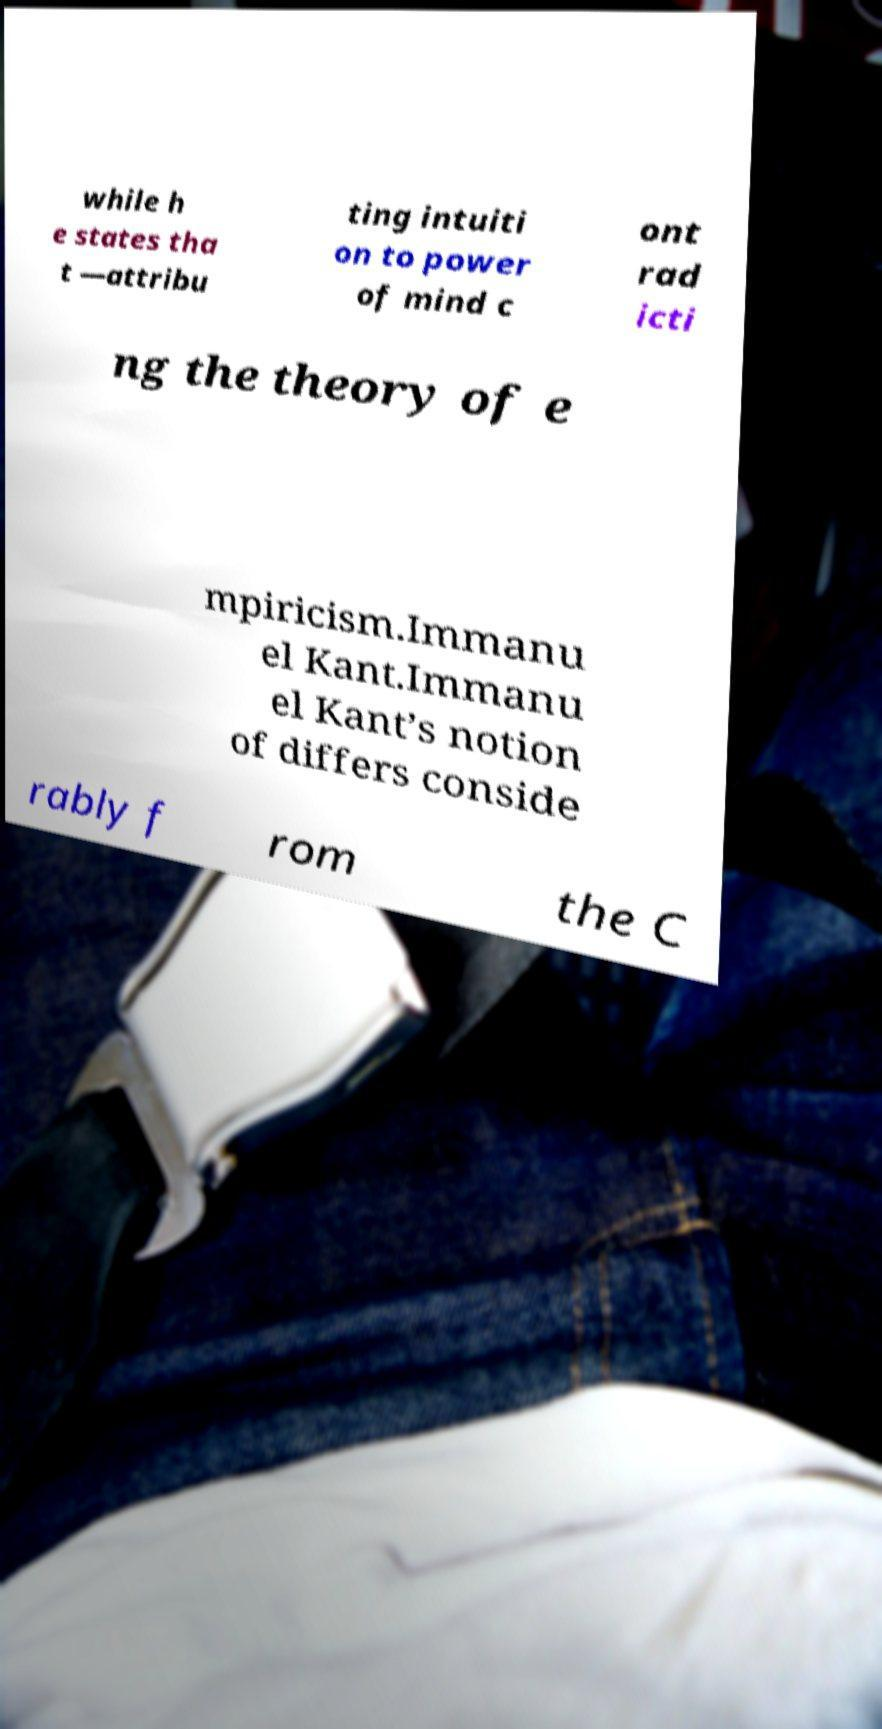What messages or text are displayed in this image? I need them in a readable, typed format. while h e states tha t —attribu ting intuiti on to power of mind c ont rad icti ng the theory of e mpiricism.Immanu el Kant.Immanu el Kant’s notion of differs conside rably f rom the C 